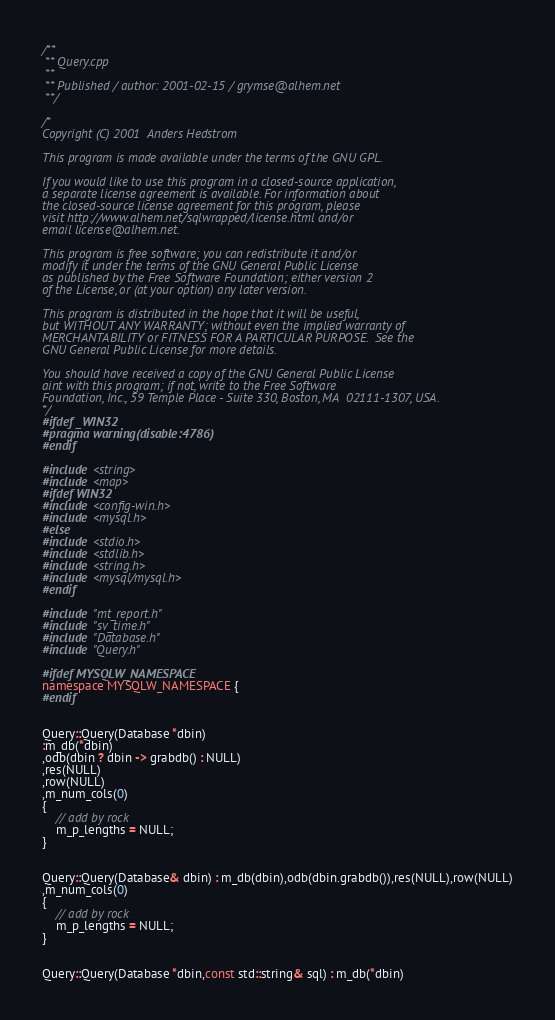Convert code to text. <code><loc_0><loc_0><loc_500><loc_500><_C++_>/**
 **	Query.cpp
 **
 **	Published / author: 2001-02-15 / grymse@alhem.net
 **/

/*
Copyright (C) 2001  Anders Hedstrom

This program is made available under the terms of the GNU GPL.

If you would like to use this program in a closed-source application,
a separate license agreement is available. For information about 
the closed-source license agreement for this program, please
visit http://www.alhem.net/sqlwrapped/license.html and/or
email license@alhem.net.

This program is free software; you can redistribute it and/or
modify it under the terms of the GNU General Public License
as published by the Free Software Foundation; either version 2
of the License, or (at your option) any later version.

This program is distributed in the hope that it will be useful,
but WITHOUT ANY WARRANTY; without even the implied warranty of
MERCHANTABILITY or FITNESS FOR A PARTICULAR PURPOSE.  See the
GNU General Public License for more details.

You should have received a copy of the GNU General Public License
aint with this program; if not, write to the Free Software
Foundation, Inc., 59 Temple Place - Suite 330, Boston, MA  02111-1307, USA.
*/
#ifdef _WIN32
#pragma warning(disable:4786)
#endif

#include <string>
#include <map>
#ifdef WIN32
#include <config-win.h>
#include <mysql.h>
#else
#include <stdio.h>
#include <stdlib.h>
#include <string.h>
#include <mysql/mysql.h>
#endif

#include "mt_report.h"
#include "sv_time.h"
#include "Database.h"
#include "Query.h"

#ifdef MYSQLW_NAMESPACE
namespace MYSQLW_NAMESPACE {
#endif


Query::Query(Database *dbin)
:m_db(*dbin)
,odb(dbin ? dbin -> grabdb() : NULL)
,res(NULL)
,row(NULL)
,m_num_cols(0)
{
	// add by rock
	m_p_lengths = NULL;
}


Query::Query(Database& dbin) : m_db(dbin),odb(dbin.grabdb()),res(NULL),row(NULL)
,m_num_cols(0)
{
	// add by rock
	m_p_lengths = NULL;
}


Query::Query(Database *dbin,const std::string& sql) : m_db(*dbin)</code> 